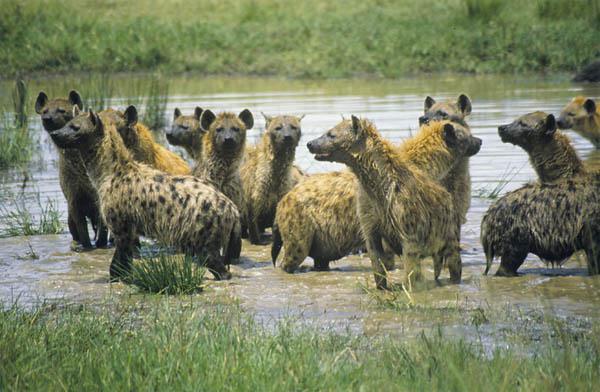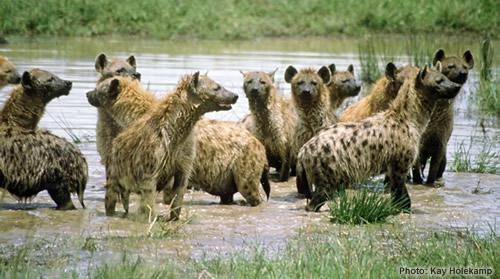The first image is the image on the left, the second image is the image on the right. For the images displayed, is the sentence "At least one image shows hyenas around an animal carcass." factually correct? Answer yes or no. No. The first image is the image on the left, the second image is the image on the right. Examine the images to the left and right. Is the description "Some of the animals are eating their prey." accurate? Answer yes or no. No. 